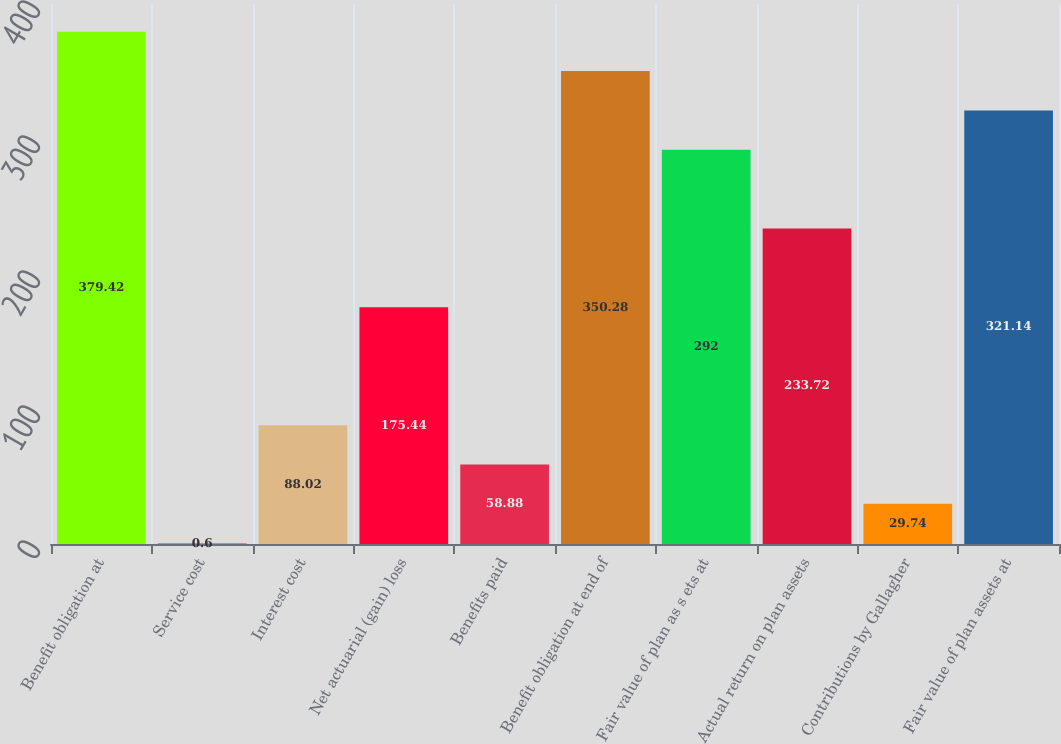Convert chart to OTSL. <chart><loc_0><loc_0><loc_500><loc_500><bar_chart><fcel>Benefit obligation at<fcel>Service cost<fcel>Interest cost<fcel>Net actuarial (gain) loss<fcel>Benefits paid<fcel>Benefit obligation at end of<fcel>Fair value of plan as s ets at<fcel>Actual return on plan assets<fcel>Contributions by Gallagher<fcel>Fair value of plan assets at<nl><fcel>379.42<fcel>0.6<fcel>88.02<fcel>175.44<fcel>58.88<fcel>350.28<fcel>292<fcel>233.72<fcel>29.74<fcel>321.14<nl></chart> 